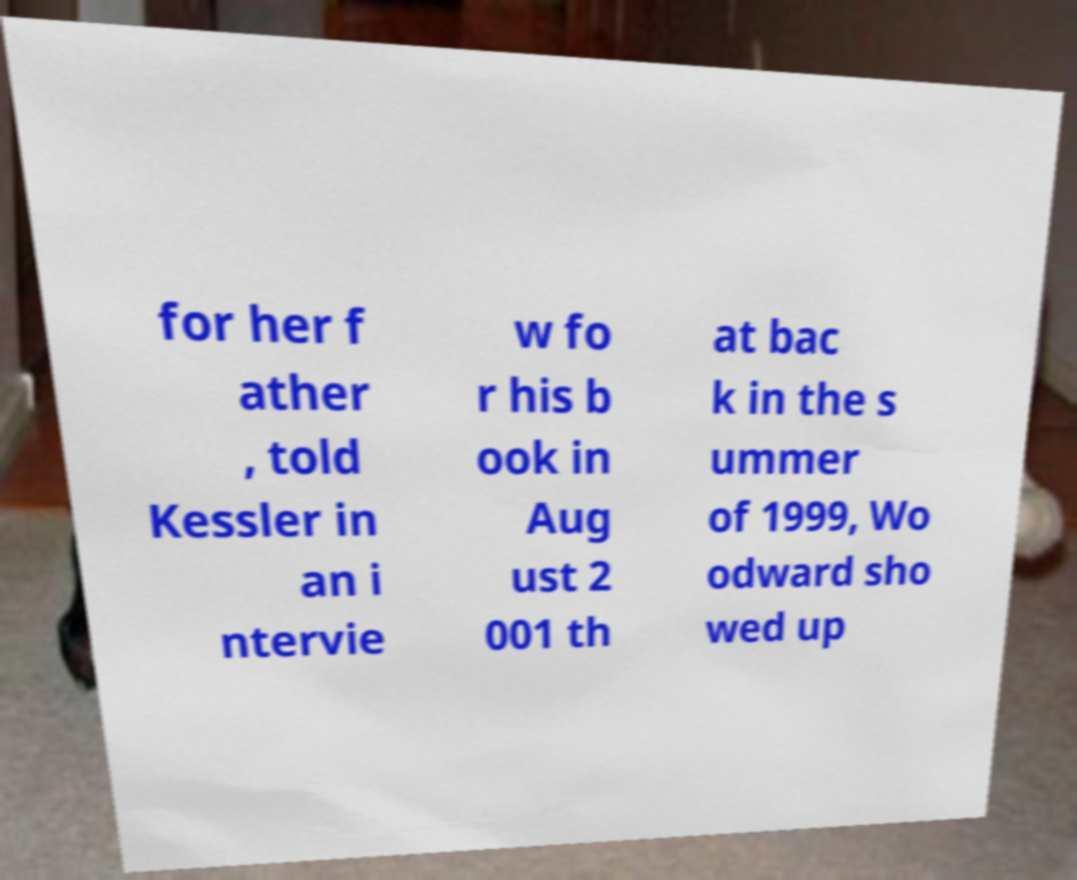What messages or text are displayed in this image? I need them in a readable, typed format. for her f ather , told Kessler in an i ntervie w fo r his b ook in Aug ust 2 001 th at bac k in the s ummer of 1999, Wo odward sho wed up 